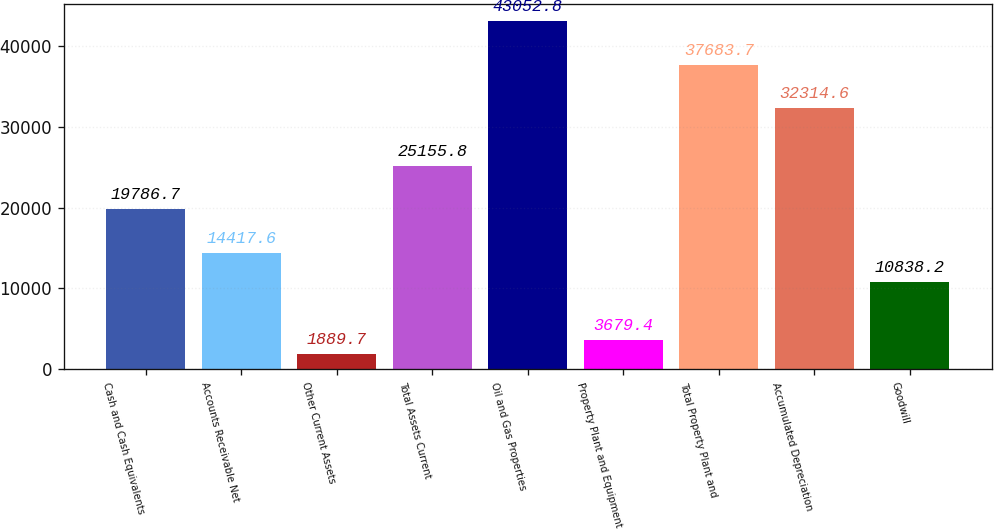<chart> <loc_0><loc_0><loc_500><loc_500><bar_chart><fcel>Cash and Cash Equivalents<fcel>Accounts Receivable Net<fcel>Other Current Assets<fcel>Total Assets Current<fcel>Oil and Gas Properties<fcel>Property Plant and Equipment<fcel>Total Property Plant and<fcel>Accumulated Depreciation<fcel>Goodwill<nl><fcel>19786.7<fcel>14417.6<fcel>1889.7<fcel>25155.8<fcel>43052.8<fcel>3679.4<fcel>37683.7<fcel>32314.6<fcel>10838.2<nl></chart> 